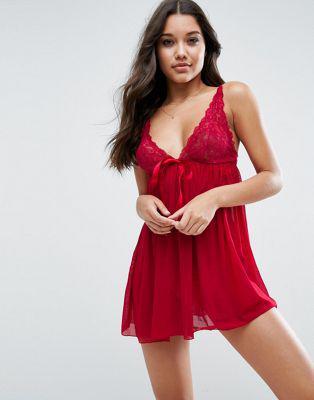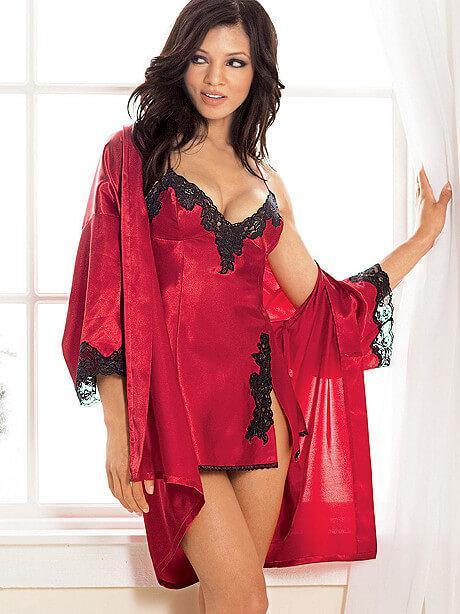The first image is the image on the left, the second image is the image on the right. For the images displayed, is the sentence "At least one image shows a woman standing." factually correct? Answer yes or no. Yes. The first image is the image on the left, the second image is the image on the right. Assess this claim about the two images: "The image on the right has a model standing on her feet wearing lingerie.". Correct or not? Answer yes or no. Yes. 